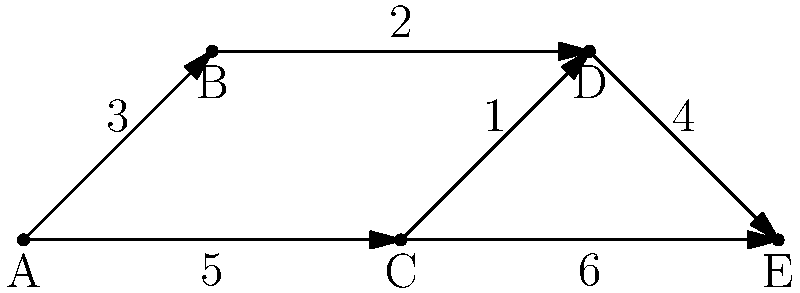In a merger network, companies are represented as nodes, and potential merger paths are represented as edges with associated costs. Given the network shown in the diagram, where A is your company and E is the target company for acquisition, what is the lowest total cost to reach company E from A using Dijkstra's algorithm? To solve this problem using Dijkstra's algorithm, we'll follow these steps:

1) Initialize:
   - Set distance to A as 0
   - Set distances to all other nodes as infinity
   - Set A as the current node

2) For the current node, consider all unvisited neighbors and calculate their tentative distances:
   - A to B: 3
   - A to C: 5

3) Set A as visited. B has the smallest tentative distance, so make B the current node.

4) From B:
   - B to D: 3 (from A) + 2 = 5

5) Set B as visited. C has the smallest tentative distance among unvisited nodes, so make C the current node.

6) From C:
   - C to D: 5 (from A) + 1 = 6 (doesn't improve D's distance)
   - C to E: 5 (from A) + 6 = 11

7) Set C as visited. D has the smallest tentative distance among unvisited nodes, so make D the current node.

8) From D:
   - D to E: 5 (from B) + 4 = 9 (improves E's distance)

9) Set D as visited. E is the only unvisited node left.

The shortest path from A to E is A -> B -> D -> E with a total cost of 9.
Answer: 9 